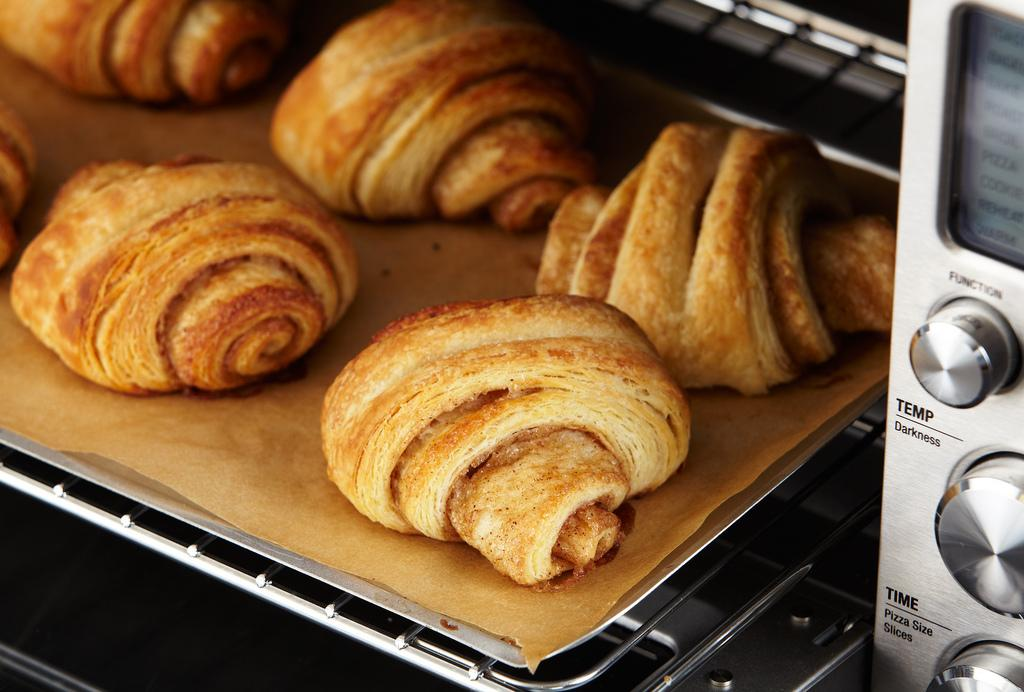What type of food can be seen in the image? There is baked food in the image. How is the baked food arranged or presented? The baked food is placed on a tray. What appliance is visible on the right side of the image? There is a microwave oven on the right side of the image. Can you see any cubs playing on the grass near the bridge in the image? There is no mention of cubs, grass, or a bridge in the image; it only features baked food on a tray and a microwave oven. 